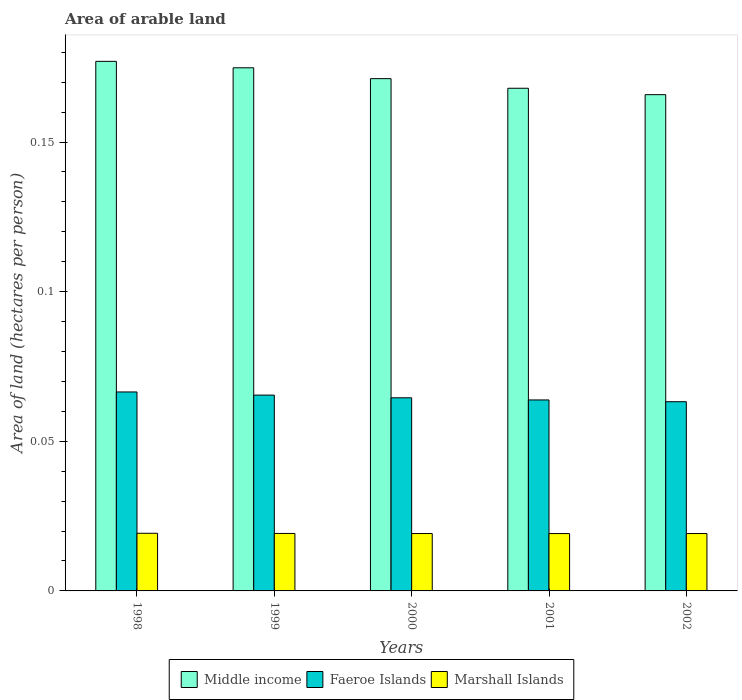Are the number of bars per tick equal to the number of legend labels?
Ensure brevity in your answer.  Yes. How many bars are there on the 3rd tick from the left?
Provide a succinct answer. 3. How many bars are there on the 5th tick from the right?
Your answer should be very brief. 3. What is the total arable land in Marshall Islands in 1998?
Your answer should be very brief. 0.02. Across all years, what is the maximum total arable land in Faeroe Islands?
Your answer should be compact. 0.07. Across all years, what is the minimum total arable land in Faeroe Islands?
Offer a terse response. 0.06. In which year was the total arable land in Faeroe Islands minimum?
Give a very brief answer. 2002. What is the total total arable land in Faeroe Islands in the graph?
Offer a terse response. 0.32. What is the difference between the total arable land in Marshall Islands in 1999 and that in 2002?
Offer a terse response. 3.1292149651300505e-5. What is the difference between the total arable land in Faeroe Islands in 2002 and the total arable land in Middle income in 1999?
Ensure brevity in your answer.  -0.11. What is the average total arable land in Faeroe Islands per year?
Your answer should be compact. 0.06. In the year 1999, what is the difference between the total arable land in Middle income and total arable land in Faeroe Islands?
Your answer should be very brief. 0.11. What is the ratio of the total arable land in Marshall Islands in 1998 to that in 2002?
Make the answer very short. 1. Is the total arable land in Faeroe Islands in 2000 less than that in 2001?
Keep it short and to the point. No. What is the difference between the highest and the second highest total arable land in Middle income?
Offer a very short reply. 0. What is the difference between the highest and the lowest total arable land in Middle income?
Make the answer very short. 0.01. Is the sum of the total arable land in Marshall Islands in 1999 and 2000 greater than the maximum total arable land in Faeroe Islands across all years?
Offer a very short reply. No. What does the 2nd bar from the left in 2000 represents?
Offer a terse response. Faeroe Islands. What does the 1st bar from the right in 2000 represents?
Ensure brevity in your answer.  Marshall Islands. How many bars are there?
Your response must be concise. 15. What is the difference between two consecutive major ticks on the Y-axis?
Provide a short and direct response. 0.05. Does the graph contain any zero values?
Offer a terse response. No. Does the graph contain grids?
Your answer should be compact. No. Where does the legend appear in the graph?
Offer a very short reply. Bottom center. What is the title of the graph?
Your answer should be very brief. Area of arable land. Does "High income: OECD" appear as one of the legend labels in the graph?
Ensure brevity in your answer.  No. What is the label or title of the X-axis?
Keep it short and to the point. Years. What is the label or title of the Y-axis?
Provide a short and direct response. Area of land (hectares per person). What is the Area of land (hectares per person) in Middle income in 1998?
Your answer should be very brief. 0.18. What is the Area of land (hectares per person) in Faeroe Islands in 1998?
Your response must be concise. 0.07. What is the Area of land (hectares per person) of Marshall Islands in 1998?
Keep it short and to the point. 0.02. What is the Area of land (hectares per person) in Middle income in 1999?
Your answer should be compact. 0.17. What is the Area of land (hectares per person) of Faeroe Islands in 1999?
Provide a succinct answer. 0.07. What is the Area of land (hectares per person) in Marshall Islands in 1999?
Your answer should be very brief. 0.02. What is the Area of land (hectares per person) in Middle income in 2000?
Offer a terse response. 0.17. What is the Area of land (hectares per person) of Faeroe Islands in 2000?
Offer a terse response. 0.06. What is the Area of land (hectares per person) in Marshall Islands in 2000?
Ensure brevity in your answer.  0.02. What is the Area of land (hectares per person) in Middle income in 2001?
Your response must be concise. 0.17. What is the Area of land (hectares per person) of Faeroe Islands in 2001?
Provide a succinct answer. 0.06. What is the Area of land (hectares per person) of Marshall Islands in 2001?
Give a very brief answer. 0.02. What is the Area of land (hectares per person) in Middle income in 2002?
Your answer should be very brief. 0.17. What is the Area of land (hectares per person) in Faeroe Islands in 2002?
Make the answer very short. 0.06. What is the Area of land (hectares per person) of Marshall Islands in 2002?
Provide a short and direct response. 0.02. Across all years, what is the maximum Area of land (hectares per person) of Middle income?
Keep it short and to the point. 0.18. Across all years, what is the maximum Area of land (hectares per person) of Faeroe Islands?
Offer a very short reply. 0.07. Across all years, what is the maximum Area of land (hectares per person) in Marshall Islands?
Provide a succinct answer. 0.02. Across all years, what is the minimum Area of land (hectares per person) in Middle income?
Your answer should be compact. 0.17. Across all years, what is the minimum Area of land (hectares per person) of Faeroe Islands?
Provide a short and direct response. 0.06. Across all years, what is the minimum Area of land (hectares per person) of Marshall Islands?
Keep it short and to the point. 0.02. What is the total Area of land (hectares per person) in Middle income in the graph?
Offer a terse response. 0.86. What is the total Area of land (hectares per person) of Faeroe Islands in the graph?
Keep it short and to the point. 0.32. What is the total Area of land (hectares per person) in Marshall Islands in the graph?
Offer a terse response. 0.1. What is the difference between the Area of land (hectares per person) in Middle income in 1998 and that in 1999?
Your answer should be compact. 0. What is the difference between the Area of land (hectares per person) in Faeroe Islands in 1998 and that in 1999?
Your response must be concise. 0. What is the difference between the Area of land (hectares per person) of Marshall Islands in 1998 and that in 1999?
Provide a short and direct response. 0. What is the difference between the Area of land (hectares per person) in Middle income in 1998 and that in 2000?
Your answer should be compact. 0.01. What is the difference between the Area of land (hectares per person) of Faeroe Islands in 1998 and that in 2000?
Offer a terse response. 0. What is the difference between the Area of land (hectares per person) of Marshall Islands in 1998 and that in 2000?
Make the answer very short. 0. What is the difference between the Area of land (hectares per person) of Middle income in 1998 and that in 2001?
Offer a terse response. 0.01. What is the difference between the Area of land (hectares per person) of Faeroe Islands in 1998 and that in 2001?
Keep it short and to the point. 0. What is the difference between the Area of land (hectares per person) of Marshall Islands in 1998 and that in 2001?
Make the answer very short. 0. What is the difference between the Area of land (hectares per person) of Middle income in 1998 and that in 2002?
Your response must be concise. 0.01. What is the difference between the Area of land (hectares per person) in Faeroe Islands in 1998 and that in 2002?
Your response must be concise. 0. What is the difference between the Area of land (hectares per person) of Marshall Islands in 1998 and that in 2002?
Your answer should be very brief. 0. What is the difference between the Area of land (hectares per person) in Middle income in 1999 and that in 2000?
Provide a short and direct response. 0. What is the difference between the Area of land (hectares per person) in Faeroe Islands in 1999 and that in 2000?
Make the answer very short. 0. What is the difference between the Area of land (hectares per person) in Marshall Islands in 1999 and that in 2000?
Offer a terse response. 0. What is the difference between the Area of land (hectares per person) in Middle income in 1999 and that in 2001?
Ensure brevity in your answer.  0.01. What is the difference between the Area of land (hectares per person) of Faeroe Islands in 1999 and that in 2001?
Offer a terse response. 0. What is the difference between the Area of land (hectares per person) of Middle income in 1999 and that in 2002?
Your answer should be compact. 0.01. What is the difference between the Area of land (hectares per person) of Faeroe Islands in 1999 and that in 2002?
Make the answer very short. 0. What is the difference between the Area of land (hectares per person) in Middle income in 2000 and that in 2001?
Make the answer very short. 0. What is the difference between the Area of land (hectares per person) in Faeroe Islands in 2000 and that in 2001?
Your answer should be very brief. 0. What is the difference between the Area of land (hectares per person) in Marshall Islands in 2000 and that in 2001?
Provide a succinct answer. 0. What is the difference between the Area of land (hectares per person) in Middle income in 2000 and that in 2002?
Provide a short and direct response. 0.01. What is the difference between the Area of land (hectares per person) in Faeroe Islands in 2000 and that in 2002?
Your answer should be compact. 0. What is the difference between the Area of land (hectares per person) in Marshall Islands in 2000 and that in 2002?
Your response must be concise. 0. What is the difference between the Area of land (hectares per person) in Middle income in 2001 and that in 2002?
Provide a short and direct response. 0. What is the difference between the Area of land (hectares per person) of Faeroe Islands in 2001 and that in 2002?
Your answer should be compact. 0. What is the difference between the Area of land (hectares per person) of Middle income in 1998 and the Area of land (hectares per person) of Faeroe Islands in 1999?
Offer a very short reply. 0.11. What is the difference between the Area of land (hectares per person) of Middle income in 1998 and the Area of land (hectares per person) of Marshall Islands in 1999?
Your answer should be very brief. 0.16. What is the difference between the Area of land (hectares per person) in Faeroe Islands in 1998 and the Area of land (hectares per person) in Marshall Islands in 1999?
Make the answer very short. 0.05. What is the difference between the Area of land (hectares per person) in Middle income in 1998 and the Area of land (hectares per person) in Faeroe Islands in 2000?
Give a very brief answer. 0.11. What is the difference between the Area of land (hectares per person) in Middle income in 1998 and the Area of land (hectares per person) in Marshall Islands in 2000?
Your answer should be compact. 0.16. What is the difference between the Area of land (hectares per person) of Faeroe Islands in 1998 and the Area of land (hectares per person) of Marshall Islands in 2000?
Your answer should be compact. 0.05. What is the difference between the Area of land (hectares per person) of Middle income in 1998 and the Area of land (hectares per person) of Faeroe Islands in 2001?
Give a very brief answer. 0.11. What is the difference between the Area of land (hectares per person) in Middle income in 1998 and the Area of land (hectares per person) in Marshall Islands in 2001?
Make the answer very short. 0.16. What is the difference between the Area of land (hectares per person) in Faeroe Islands in 1998 and the Area of land (hectares per person) in Marshall Islands in 2001?
Your answer should be very brief. 0.05. What is the difference between the Area of land (hectares per person) in Middle income in 1998 and the Area of land (hectares per person) in Faeroe Islands in 2002?
Your answer should be very brief. 0.11. What is the difference between the Area of land (hectares per person) of Middle income in 1998 and the Area of land (hectares per person) of Marshall Islands in 2002?
Keep it short and to the point. 0.16. What is the difference between the Area of land (hectares per person) in Faeroe Islands in 1998 and the Area of land (hectares per person) in Marshall Islands in 2002?
Make the answer very short. 0.05. What is the difference between the Area of land (hectares per person) in Middle income in 1999 and the Area of land (hectares per person) in Faeroe Islands in 2000?
Your answer should be compact. 0.11. What is the difference between the Area of land (hectares per person) in Middle income in 1999 and the Area of land (hectares per person) in Marshall Islands in 2000?
Your response must be concise. 0.16. What is the difference between the Area of land (hectares per person) of Faeroe Islands in 1999 and the Area of land (hectares per person) of Marshall Islands in 2000?
Your answer should be compact. 0.05. What is the difference between the Area of land (hectares per person) of Middle income in 1999 and the Area of land (hectares per person) of Faeroe Islands in 2001?
Keep it short and to the point. 0.11. What is the difference between the Area of land (hectares per person) in Middle income in 1999 and the Area of land (hectares per person) in Marshall Islands in 2001?
Provide a short and direct response. 0.16. What is the difference between the Area of land (hectares per person) of Faeroe Islands in 1999 and the Area of land (hectares per person) of Marshall Islands in 2001?
Provide a succinct answer. 0.05. What is the difference between the Area of land (hectares per person) of Middle income in 1999 and the Area of land (hectares per person) of Faeroe Islands in 2002?
Keep it short and to the point. 0.11. What is the difference between the Area of land (hectares per person) in Middle income in 1999 and the Area of land (hectares per person) in Marshall Islands in 2002?
Your answer should be compact. 0.16. What is the difference between the Area of land (hectares per person) of Faeroe Islands in 1999 and the Area of land (hectares per person) of Marshall Islands in 2002?
Your response must be concise. 0.05. What is the difference between the Area of land (hectares per person) of Middle income in 2000 and the Area of land (hectares per person) of Faeroe Islands in 2001?
Your answer should be very brief. 0.11. What is the difference between the Area of land (hectares per person) of Middle income in 2000 and the Area of land (hectares per person) of Marshall Islands in 2001?
Provide a succinct answer. 0.15. What is the difference between the Area of land (hectares per person) of Faeroe Islands in 2000 and the Area of land (hectares per person) of Marshall Islands in 2001?
Provide a short and direct response. 0.05. What is the difference between the Area of land (hectares per person) in Middle income in 2000 and the Area of land (hectares per person) in Faeroe Islands in 2002?
Give a very brief answer. 0.11. What is the difference between the Area of land (hectares per person) of Middle income in 2000 and the Area of land (hectares per person) of Marshall Islands in 2002?
Your response must be concise. 0.15. What is the difference between the Area of land (hectares per person) of Faeroe Islands in 2000 and the Area of land (hectares per person) of Marshall Islands in 2002?
Your answer should be compact. 0.05. What is the difference between the Area of land (hectares per person) in Middle income in 2001 and the Area of land (hectares per person) in Faeroe Islands in 2002?
Your answer should be very brief. 0.1. What is the difference between the Area of land (hectares per person) in Middle income in 2001 and the Area of land (hectares per person) in Marshall Islands in 2002?
Your answer should be very brief. 0.15. What is the difference between the Area of land (hectares per person) in Faeroe Islands in 2001 and the Area of land (hectares per person) in Marshall Islands in 2002?
Give a very brief answer. 0.04. What is the average Area of land (hectares per person) of Middle income per year?
Make the answer very short. 0.17. What is the average Area of land (hectares per person) of Faeroe Islands per year?
Ensure brevity in your answer.  0.06. What is the average Area of land (hectares per person) of Marshall Islands per year?
Ensure brevity in your answer.  0.02. In the year 1998, what is the difference between the Area of land (hectares per person) in Middle income and Area of land (hectares per person) in Faeroe Islands?
Offer a very short reply. 0.11. In the year 1998, what is the difference between the Area of land (hectares per person) in Middle income and Area of land (hectares per person) in Marshall Islands?
Give a very brief answer. 0.16. In the year 1998, what is the difference between the Area of land (hectares per person) of Faeroe Islands and Area of land (hectares per person) of Marshall Islands?
Keep it short and to the point. 0.05. In the year 1999, what is the difference between the Area of land (hectares per person) in Middle income and Area of land (hectares per person) in Faeroe Islands?
Keep it short and to the point. 0.11. In the year 1999, what is the difference between the Area of land (hectares per person) of Middle income and Area of land (hectares per person) of Marshall Islands?
Make the answer very short. 0.16. In the year 1999, what is the difference between the Area of land (hectares per person) in Faeroe Islands and Area of land (hectares per person) in Marshall Islands?
Provide a short and direct response. 0.05. In the year 2000, what is the difference between the Area of land (hectares per person) in Middle income and Area of land (hectares per person) in Faeroe Islands?
Your response must be concise. 0.11. In the year 2000, what is the difference between the Area of land (hectares per person) of Middle income and Area of land (hectares per person) of Marshall Islands?
Your answer should be compact. 0.15. In the year 2000, what is the difference between the Area of land (hectares per person) of Faeroe Islands and Area of land (hectares per person) of Marshall Islands?
Ensure brevity in your answer.  0.05. In the year 2001, what is the difference between the Area of land (hectares per person) of Middle income and Area of land (hectares per person) of Faeroe Islands?
Keep it short and to the point. 0.1. In the year 2001, what is the difference between the Area of land (hectares per person) in Middle income and Area of land (hectares per person) in Marshall Islands?
Your answer should be very brief. 0.15. In the year 2001, what is the difference between the Area of land (hectares per person) of Faeroe Islands and Area of land (hectares per person) of Marshall Islands?
Give a very brief answer. 0.04. In the year 2002, what is the difference between the Area of land (hectares per person) in Middle income and Area of land (hectares per person) in Faeroe Islands?
Ensure brevity in your answer.  0.1. In the year 2002, what is the difference between the Area of land (hectares per person) of Middle income and Area of land (hectares per person) of Marshall Islands?
Your answer should be compact. 0.15. In the year 2002, what is the difference between the Area of land (hectares per person) in Faeroe Islands and Area of land (hectares per person) in Marshall Islands?
Ensure brevity in your answer.  0.04. What is the ratio of the Area of land (hectares per person) of Middle income in 1998 to that in 1999?
Your response must be concise. 1.01. What is the ratio of the Area of land (hectares per person) in Faeroe Islands in 1998 to that in 1999?
Your answer should be compact. 1.02. What is the ratio of the Area of land (hectares per person) of Marshall Islands in 1998 to that in 1999?
Your response must be concise. 1. What is the ratio of the Area of land (hectares per person) of Middle income in 1998 to that in 2000?
Make the answer very short. 1.03. What is the ratio of the Area of land (hectares per person) of Faeroe Islands in 1998 to that in 2000?
Your response must be concise. 1.03. What is the ratio of the Area of land (hectares per person) in Middle income in 1998 to that in 2001?
Your response must be concise. 1.05. What is the ratio of the Area of land (hectares per person) of Faeroe Islands in 1998 to that in 2001?
Offer a very short reply. 1.04. What is the ratio of the Area of land (hectares per person) of Marshall Islands in 1998 to that in 2001?
Your answer should be compact. 1. What is the ratio of the Area of land (hectares per person) of Middle income in 1998 to that in 2002?
Give a very brief answer. 1.07. What is the ratio of the Area of land (hectares per person) of Faeroe Islands in 1998 to that in 2002?
Make the answer very short. 1.05. What is the ratio of the Area of land (hectares per person) in Middle income in 1999 to that in 2000?
Provide a short and direct response. 1.02. What is the ratio of the Area of land (hectares per person) in Faeroe Islands in 1999 to that in 2000?
Your response must be concise. 1.01. What is the ratio of the Area of land (hectares per person) in Middle income in 1999 to that in 2001?
Offer a very short reply. 1.04. What is the ratio of the Area of land (hectares per person) in Faeroe Islands in 1999 to that in 2001?
Provide a succinct answer. 1.03. What is the ratio of the Area of land (hectares per person) of Middle income in 1999 to that in 2002?
Offer a terse response. 1.05. What is the ratio of the Area of land (hectares per person) of Faeroe Islands in 1999 to that in 2002?
Offer a very short reply. 1.03. What is the ratio of the Area of land (hectares per person) of Marshall Islands in 1999 to that in 2002?
Provide a short and direct response. 1. What is the ratio of the Area of land (hectares per person) in Middle income in 2000 to that in 2001?
Keep it short and to the point. 1.02. What is the ratio of the Area of land (hectares per person) of Faeroe Islands in 2000 to that in 2001?
Ensure brevity in your answer.  1.01. What is the ratio of the Area of land (hectares per person) in Marshall Islands in 2000 to that in 2001?
Make the answer very short. 1. What is the ratio of the Area of land (hectares per person) in Middle income in 2000 to that in 2002?
Your answer should be compact. 1.03. What is the ratio of the Area of land (hectares per person) in Faeroe Islands in 2000 to that in 2002?
Make the answer very short. 1.02. What is the ratio of the Area of land (hectares per person) of Middle income in 2001 to that in 2002?
Give a very brief answer. 1.01. What is the ratio of the Area of land (hectares per person) of Faeroe Islands in 2001 to that in 2002?
Your response must be concise. 1.01. What is the ratio of the Area of land (hectares per person) in Marshall Islands in 2001 to that in 2002?
Keep it short and to the point. 1. What is the difference between the highest and the second highest Area of land (hectares per person) of Middle income?
Offer a terse response. 0. What is the difference between the highest and the second highest Area of land (hectares per person) of Faeroe Islands?
Ensure brevity in your answer.  0. What is the difference between the highest and the lowest Area of land (hectares per person) of Middle income?
Your answer should be compact. 0.01. What is the difference between the highest and the lowest Area of land (hectares per person) of Faeroe Islands?
Make the answer very short. 0. 